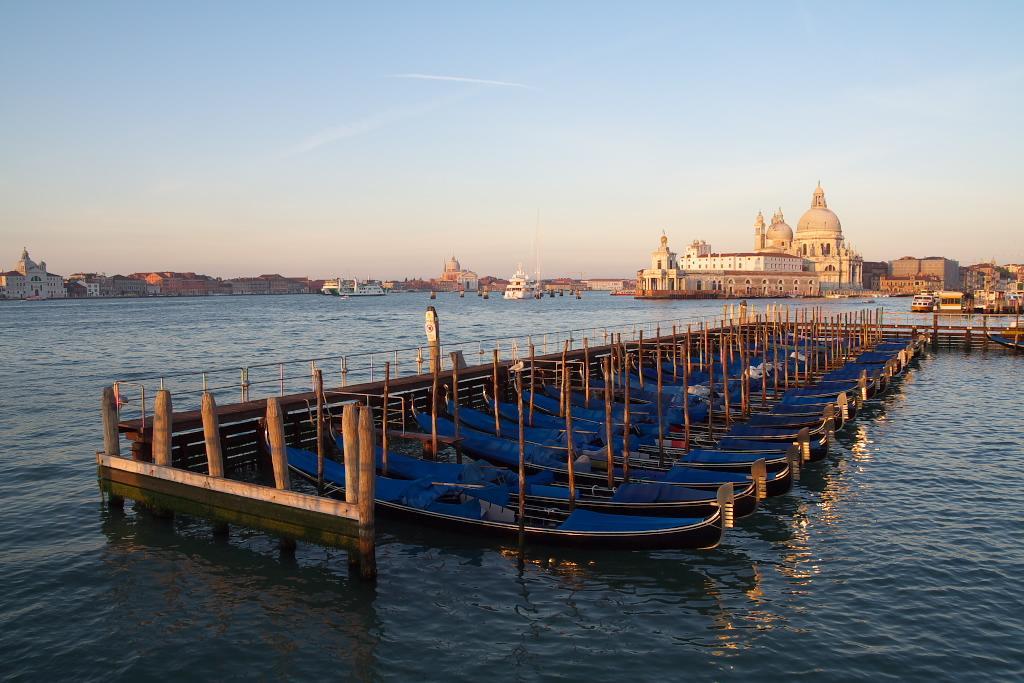How would you summarize this image in a sentence or two? In the center of the image we can see boats on the water. In the background there are buildings and sky. 